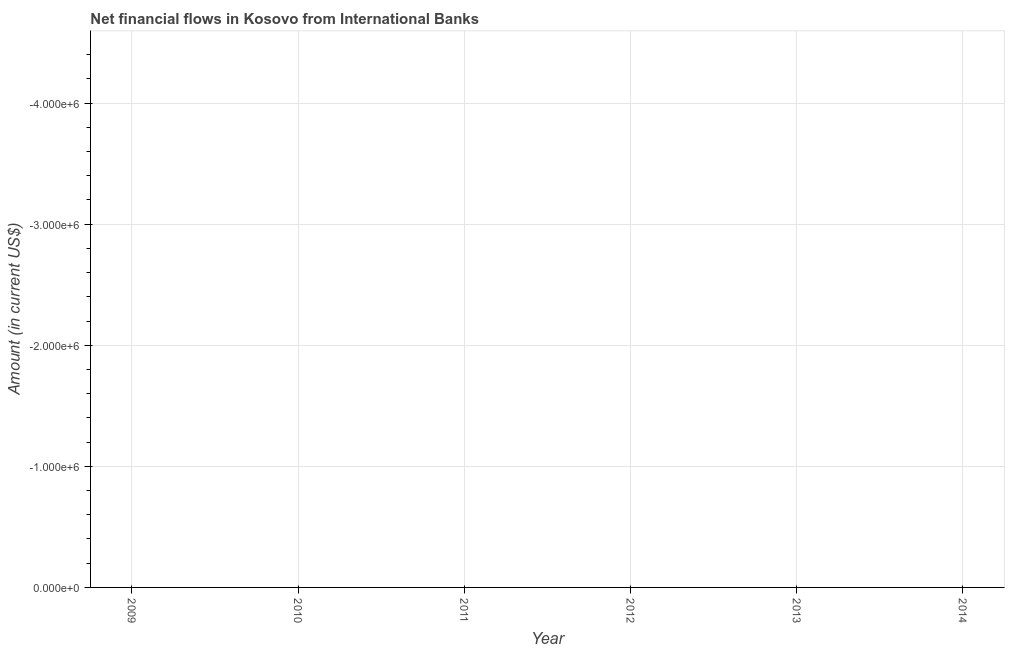What is the net financial flows from ibrd in 2014?
Your answer should be compact. 0. Across all years, what is the minimum net financial flows from ibrd?
Your answer should be compact. 0. What is the average net financial flows from ibrd per year?
Ensure brevity in your answer.  0. What is the median net financial flows from ibrd?
Keep it short and to the point. 0. In how many years, is the net financial flows from ibrd greater than -2000000 US$?
Provide a succinct answer. 0. How many lines are there?
Ensure brevity in your answer.  0. Does the graph contain grids?
Provide a short and direct response. Yes. What is the title of the graph?
Your response must be concise. Net financial flows in Kosovo from International Banks. What is the label or title of the X-axis?
Your answer should be very brief. Year. What is the Amount (in current US$) in 2009?
Your response must be concise. 0. What is the Amount (in current US$) in 2011?
Provide a short and direct response. 0. What is the Amount (in current US$) in 2013?
Offer a terse response. 0. 